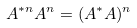<formula> <loc_0><loc_0><loc_500><loc_500>A ^ { * n } A ^ { n } = ( A ^ { * } A ) ^ { n }</formula> 